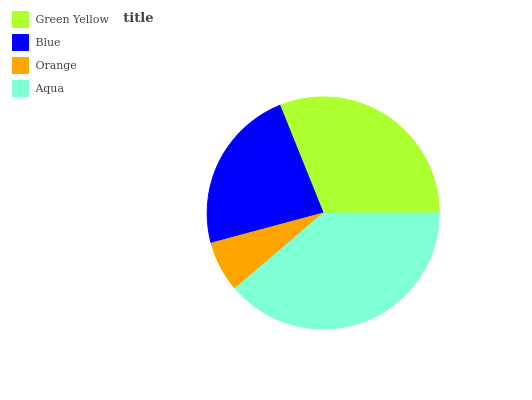Is Orange the minimum?
Answer yes or no. Yes. Is Aqua the maximum?
Answer yes or no. Yes. Is Blue the minimum?
Answer yes or no. No. Is Blue the maximum?
Answer yes or no. No. Is Green Yellow greater than Blue?
Answer yes or no. Yes. Is Blue less than Green Yellow?
Answer yes or no. Yes. Is Blue greater than Green Yellow?
Answer yes or no. No. Is Green Yellow less than Blue?
Answer yes or no. No. Is Green Yellow the high median?
Answer yes or no. Yes. Is Blue the low median?
Answer yes or no. Yes. Is Blue the high median?
Answer yes or no. No. Is Aqua the low median?
Answer yes or no. No. 